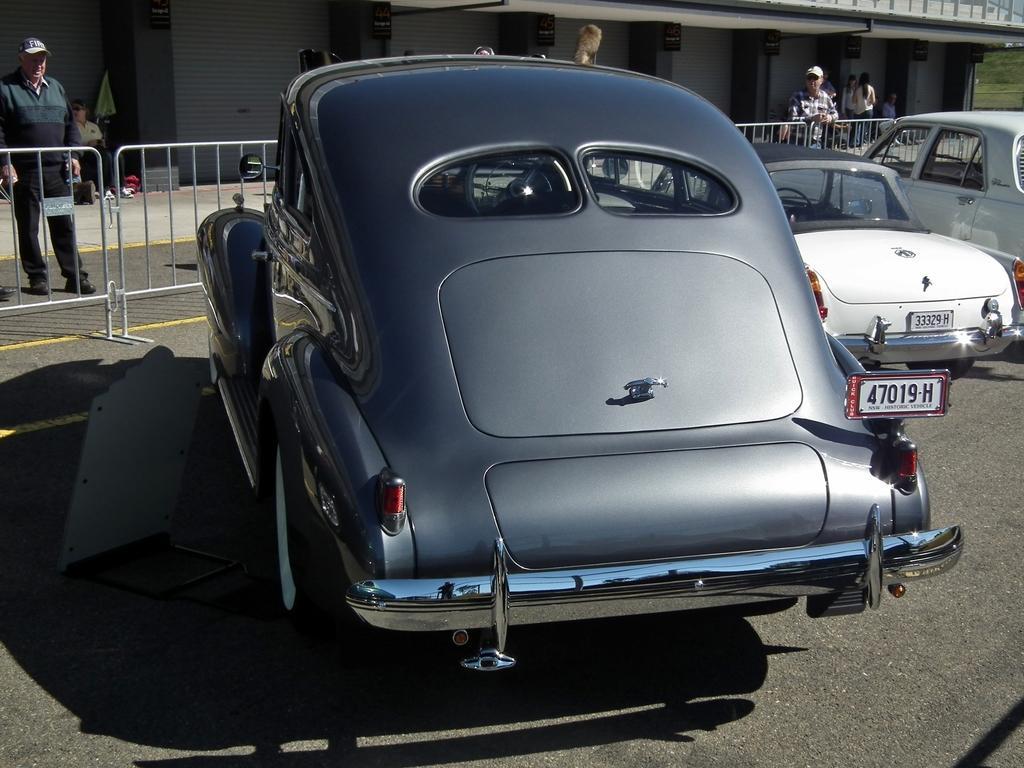Could you give a brief overview of what you see in this image? In this picture, we can see a few vehicles, road, fencing, a few people, building, and the ground with grass. 